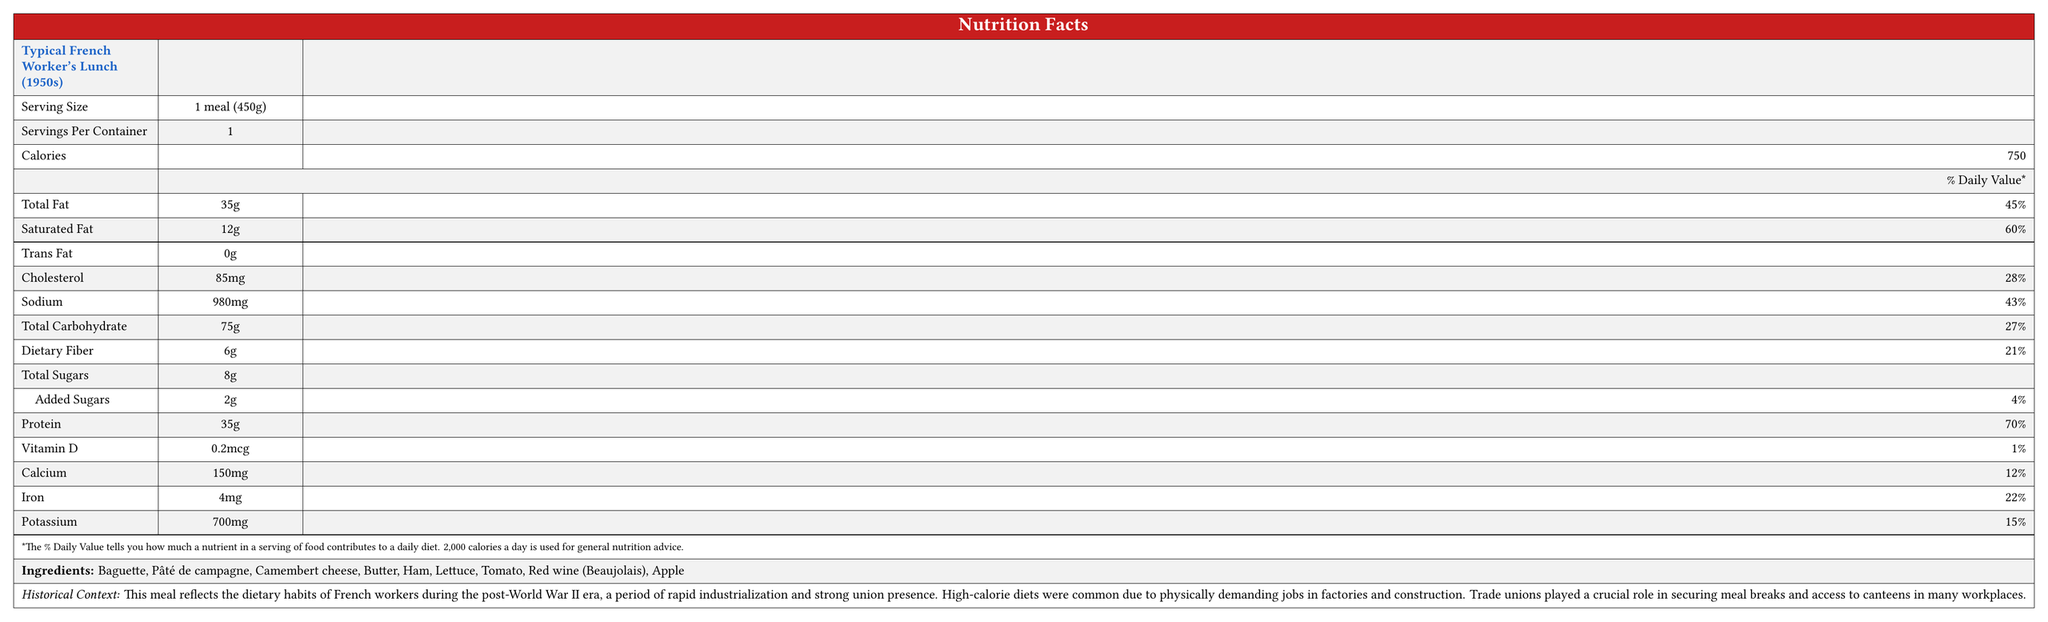what is the serving size of the lunch? The document states under the "Serving Size" that it is "1 meal (450g)."
Answer: 1 meal (450g) how many calories are in one serving? The document displays "Calories: 750" for one serving.
Answer: 750 which nutrient has the highest daily value percentage? Saturated Fat has a daily value percentage of 60%, the highest among listed nutrients.
Answer: Saturated Fat how much protein is present in the meal? The document lists "Protein: 35g."
Answer: 35g what are the main ingredients in this lunch? These ingredients are listed at the end of the document.
Answer: Baguette, Pâté de campagne, Camembert cheese, Butter, Ham, Lettuce, Tomato, Red wine (Beaujolais), Apple what percentage of the daily value of sodium does the lunch contain? The document shows "Sodium: 980mg (43%)."
Answer: 43% what are the total sugars in the meal? A. 2g B. 8g C. 6g D. 0g The total sugars are listed as 8g.
Answer: B which vitamin has the lowest daily value percentage in this meal? A. Vitamin D B. Calcium C. Iron D. Potassium Vitamin D has the lowest daily value percentage at 1%.
Answer: A does the meal contain any trans fat? The document lists "Trans Fat: 0g."
Answer: No based on the historical context, why was a high-calorie diet common during this era? The document explains that high-calorie diets were common due to the physically demanding nature of the jobs.
Answer: Due to physically demanding jobs in factories and construction compare the fat and carbohydrate content of the meal. According to the document, the meal contains 35g of total fat and 75g of total carbohydrates.
Answer: The meal contains 35g of total fat and 75g of total carbohydrates what role did trade unions play in the dietary habits of French workers? The document mentions that trade unions played a crucial role in securing meal breaks and access to canteens for workers.
Answer: They secured meal breaks and access to canteens how does the document describe the inclusion of red wine in the meal? The document states that red wine was commonly included in worker's lunches before more stringent workplace rules were established.
Answer: It was common in worker's lunches before stricter workplace regulations summarize the main idea of the document. The document details the lunch's nutritional content, ingredients, historical context, and the influence of trade unions on workers' dietary habits.
Answer: The document provides a nutritional breakdown of a typical French worker's lunch from the 1950s, highlighting its high-calorie content suitable for physically demanding work and the role of trade unions in meal provision. what is the average potassium content for a meal during this era? The document provides the potassium content for this particular meal but does not provide information for an average meal during this era.
Answer: Not enough information 